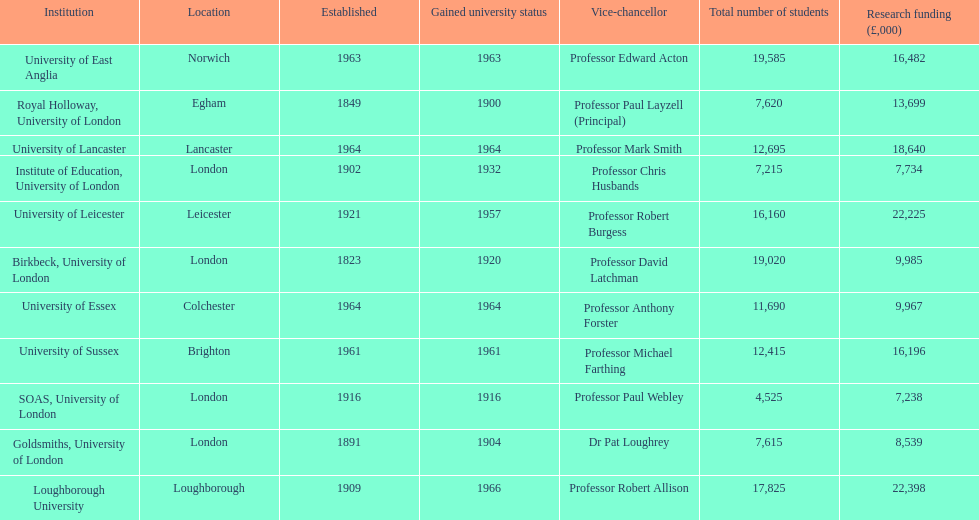What is the most recent institution to gain university status? Loughborough University. 